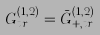<formula> <loc_0><loc_0><loc_500><loc_500>G _ { t r } ^ { ( 1 , 2 ) } = \bar { G } _ { + , t r } ^ { ( 1 , 2 ) }</formula> 